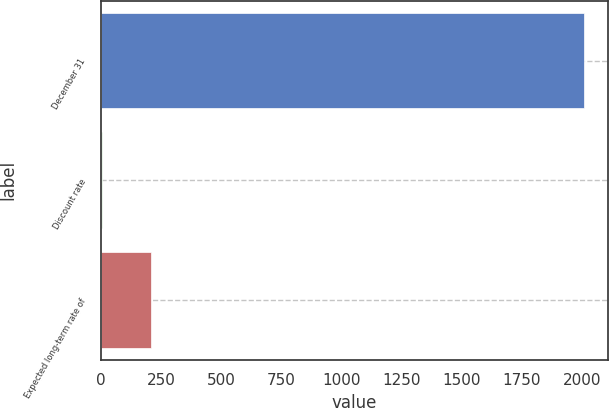Convert chart. <chart><loc_0><loc_0><loc_500><loc_500><bar_chart><fcel>December 31<fcel>Discount rate<fcel>Expected long-term rate of<nl><fcel>2009<fcel>6<fcel>206.3<nl></chart> 